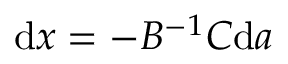Convert formula to latex. <formula><loc_0><loc_0><loc_500><loc_500>{ d } x = - B ^ { - 1 } C { d } a</formula> 